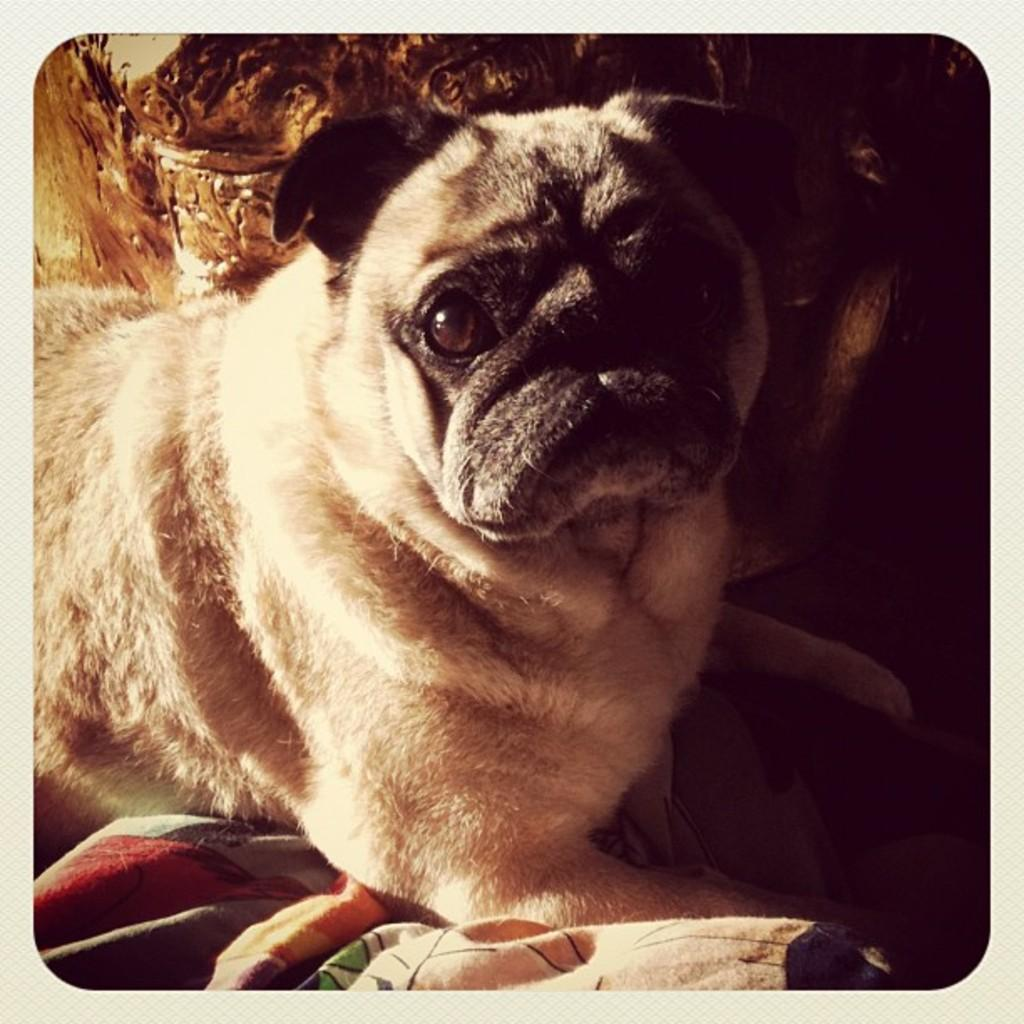What type of animal is in the image? There is a dog in the image. What object can be seen in the image besides the dog? There is a cloth in the image. How would you describe the overall lighting in the image? The background of the image is dark. What type of cheese is being served by the grandmother in the image? There is no grandmother or cheese present in the image. 